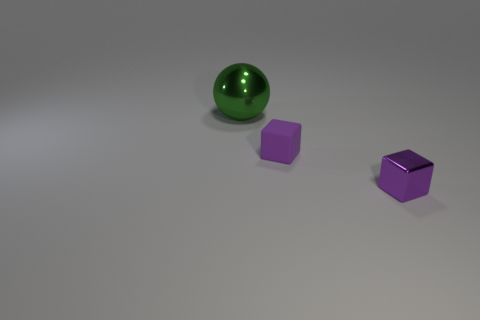The large ball that is behind the shiny thing on the right side of the thing that is to the left of the purple matte block is what color?
Make the answer very short. Green. What is the shape of the matte object?
Keep it short and to the point. Cube. There is a big thing; is it the same color as the metallic object that is in front of the big metal object?
Keep it short and to the point. No. Are there an equal number of large green objects in front of the small purple matte block and big metallic things?
Your answer should be compact. No. How many purple cubes are the same size as the purple metal thing?
Provide a succinct answer. 1. There is a small thing that is the same color as the small metallic cube; what is its shape?
Your response must be concise. Cube. Is there a small block?
Offer a very short reply. Yes. There is a shiny thing to the right of the green metallic thing; does it have the same shape as the shiny thing that is behind the tiny purple rubber thing?
Keep it short and to the point. No. What number of tiny things are shiny balls or blue matte cylinders?
Offer a terse response. 0. There is a thing that is the same material as the ball; what shape is it?
Your answer should be compact. Cube. 